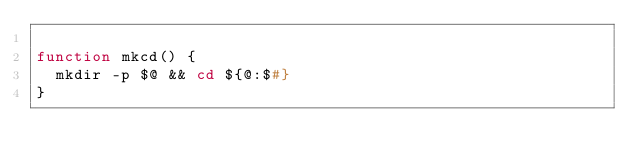<code> <loc_0><loc_0><loc_500><loc_500><_Bash_>
function mkcd() {
  mkdir -p $@ && cd ${@:$#}
}
</code> 